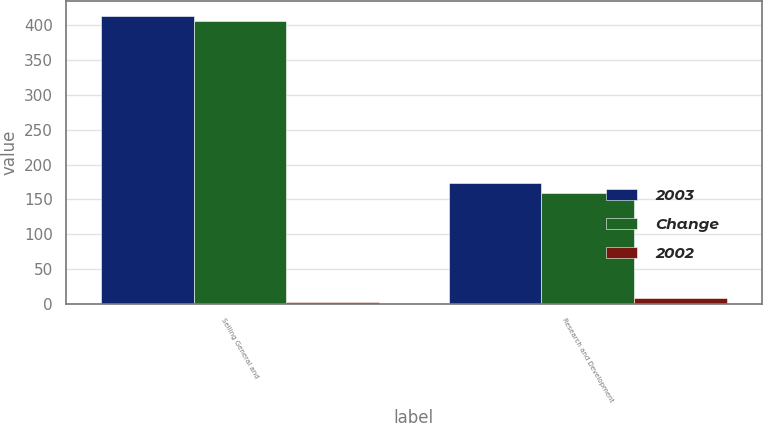Convert chart to OTSL. <chart><loc_0><loc_0><loc_500><loc_500><stacked_bar_chart><ecel><fcel>Selling General and<fcel>Research and Development<nl><fcel>2003<fcel>414<fcel>173<nl><fcel>Change<fcel>407<fcel>159<nl><fcel>2002<fcel>2<fcel>9<nl></chart> 